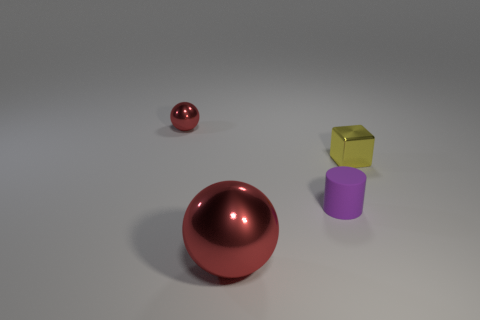Add 2 big brown rubber balls. How many objects exist? 6 Subtract 1 cubes. How many cubes are left? 0 Subtract all cylinders. How many objects are left? 3 Subtract all brown cylinders. Subtract all brown spheres. How many cylinders are left? 1 Subtract all brown cylinders. Subtract all metal spheres. How many objects are left? 2 Add 1 tiny red shiny objects. How many tiny red shiny objects are left? 2 Add 1 yellow metal cylinders. How many yellow metal cylinders exist? 1 Subtract 0 blue spheres. How many objects are left? 4 